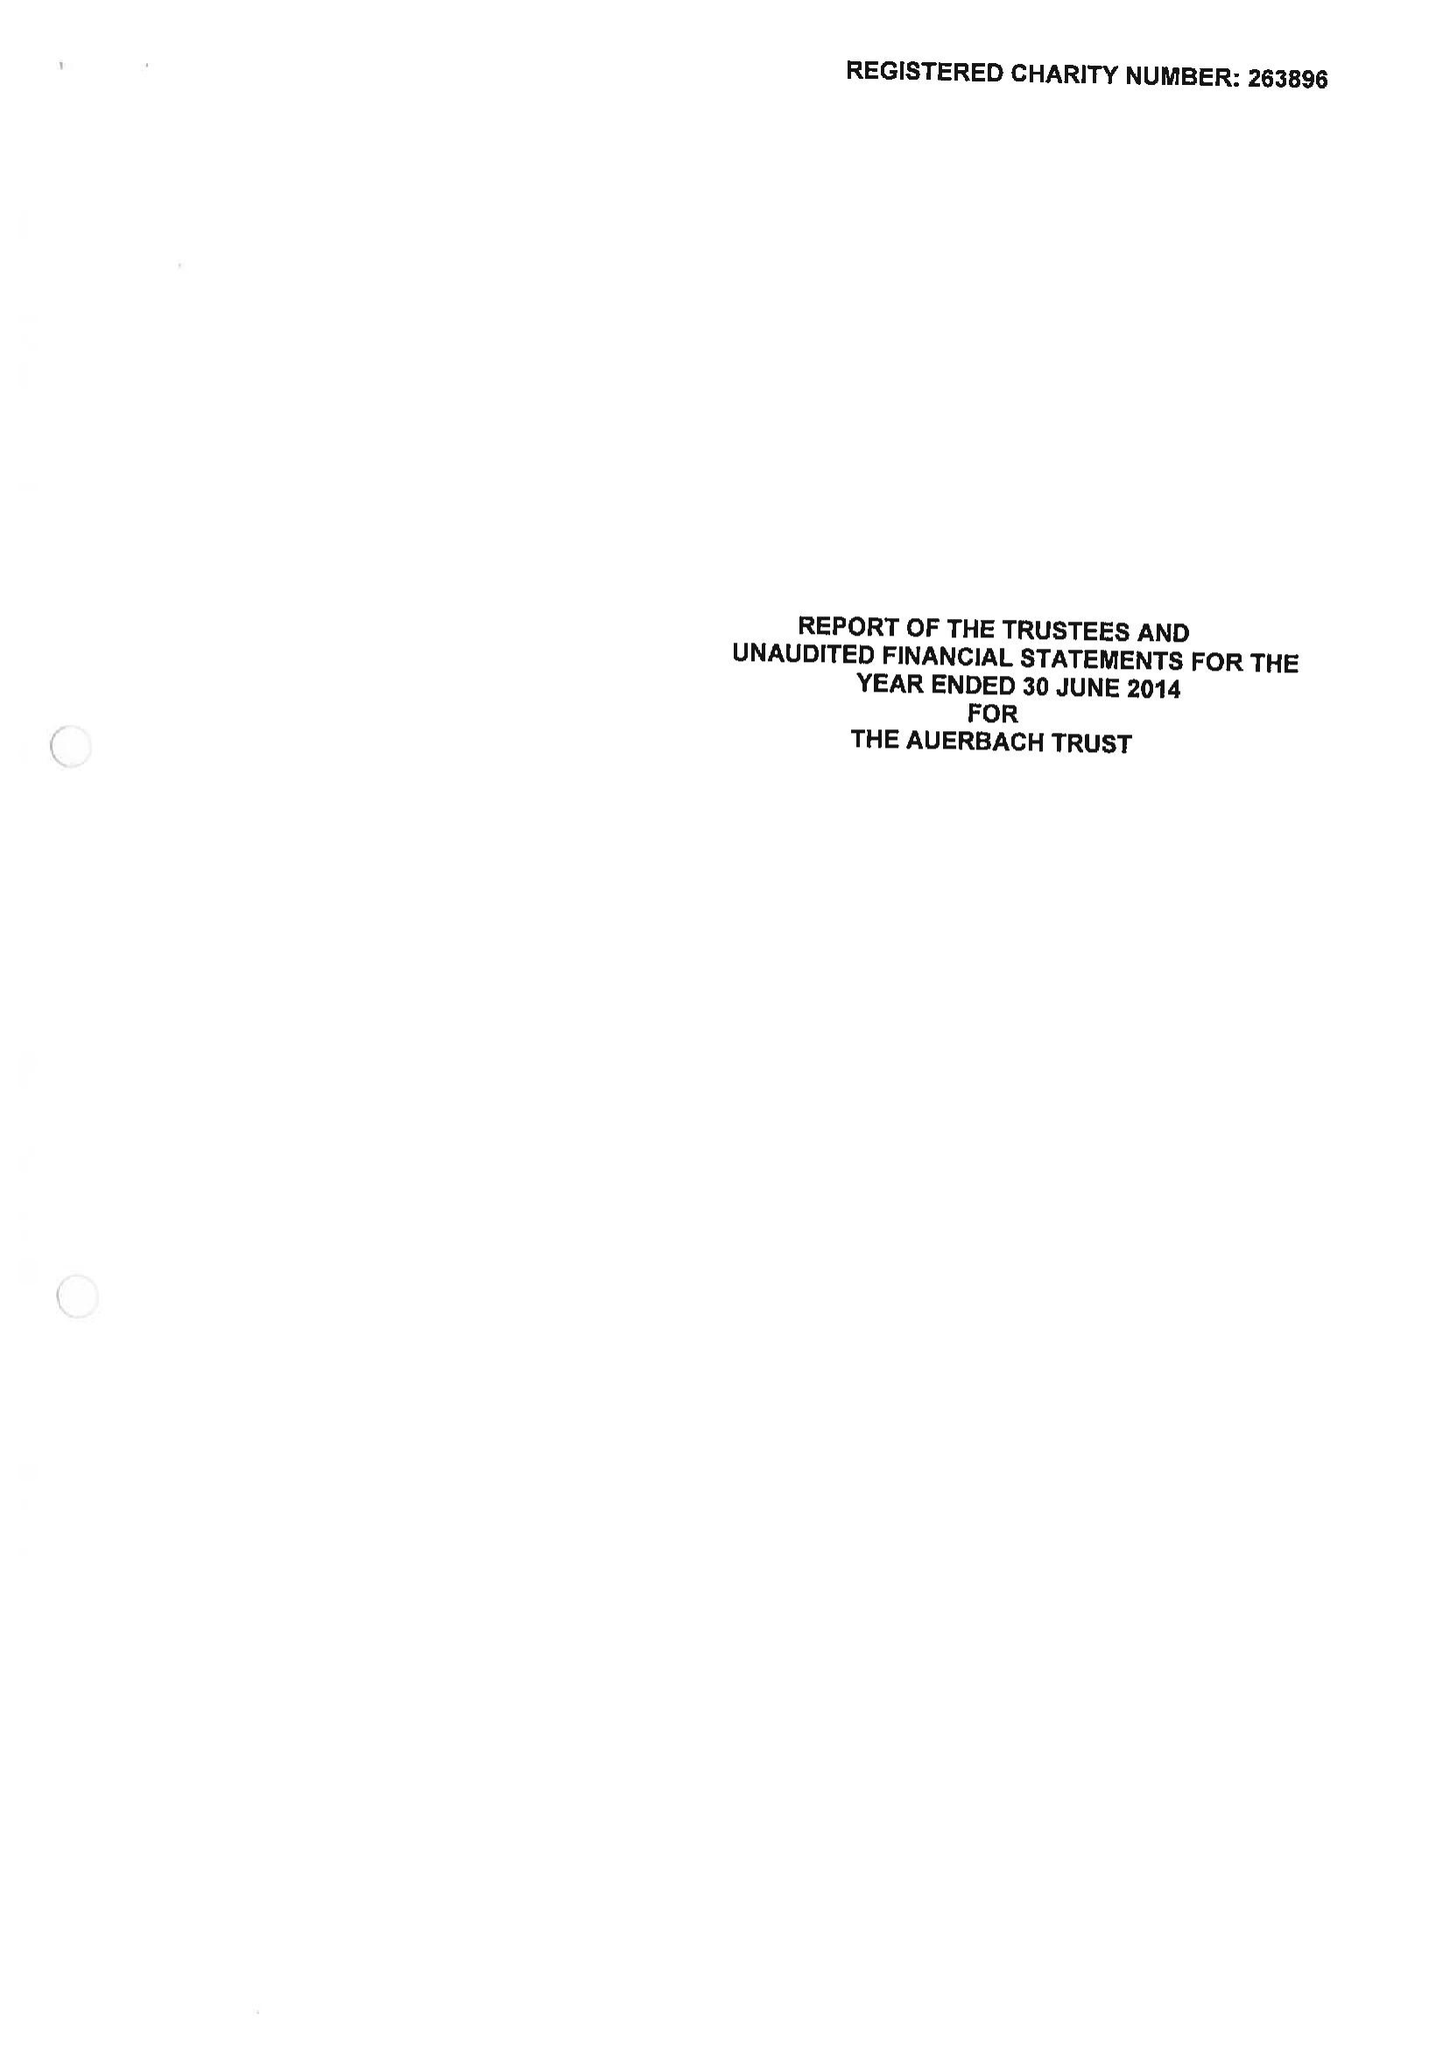What is the value for the spending_annually_in_british_pounds?
Answer the question using a single word or phrase. 17413.00 